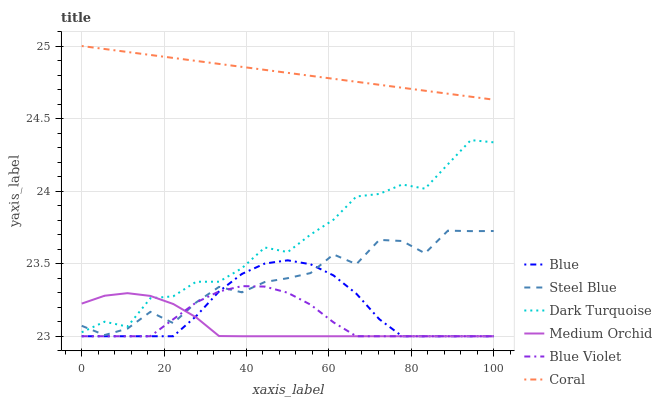Does Medium Orchid have the minimum area under the curve?
Answer yes or no. Yes. Does Coral have the maximum area under the curve?
Answer yes or no. Yes. Does Dark Turquoise have the minimum area under the curve?
Answer yes or no. No. Does Dark Turquoise have the maximum area under the curve?
Answer yes or no. No. Is Coral the smoothest?
Answer yes or no. Yes. Is Steel Blue the roughest?
Answer yes or no. Yes. Is Dark Turquoise the smoothest?
Answer yes or no. No. Is Dark Turquoise the roughest?
Answer yes or no. No. Does Dark Turquoise have the lowest value?
Answer yes or no. No. Does Coral have the highest value?
Answer yes or no. Yes. Does Dark Turquoise have the highest value?
Answer yes or no. No. Is Dark Turquoise less than Coral?
Answer yes or no. Yes. Is Coral greater than Blue Violet?
Answer yes or no. Yes. Does Steel Blue intersect Medium Orchid?
Answer yes or no. Yes. Is Steel Blue less than Medium Orchid?
Answer yes or no. No. Is Steel Blue greater than Medium Orchid?
Answer yes or no. No. Does Dark Turquoise intersect Coral?
Answer yes or no. No. 